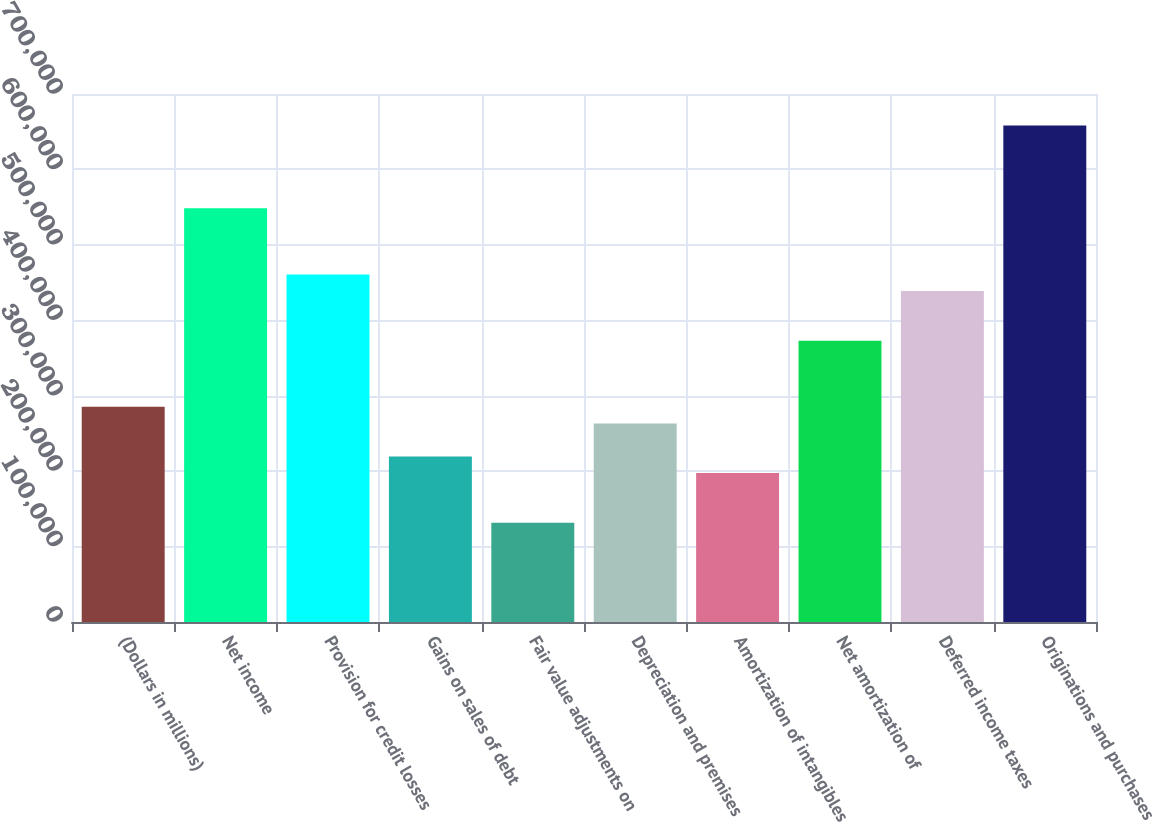<chart> <loc_0><loc_0><loc_500><loc_500><bar_chart><fcel>(Dollars in millions)<fcel>Net income<fcel>Provision for credit losses<fcel>Gains on sales of debt<fcel>Fair value adjustments on<fcel>Depreciation and premises<fcel>Amortization of intangibles<fcel>Net amortization of<fcel>Deferred income taxes<fcel>Originations and purchases<nl><fcel>285231<fcel>548506<fcel>460748<fcel>219412<fcel>131654<fcel>263291<fcel>197472<fcel>372989<fcel>438808<fcel>658204<nl></chart> 